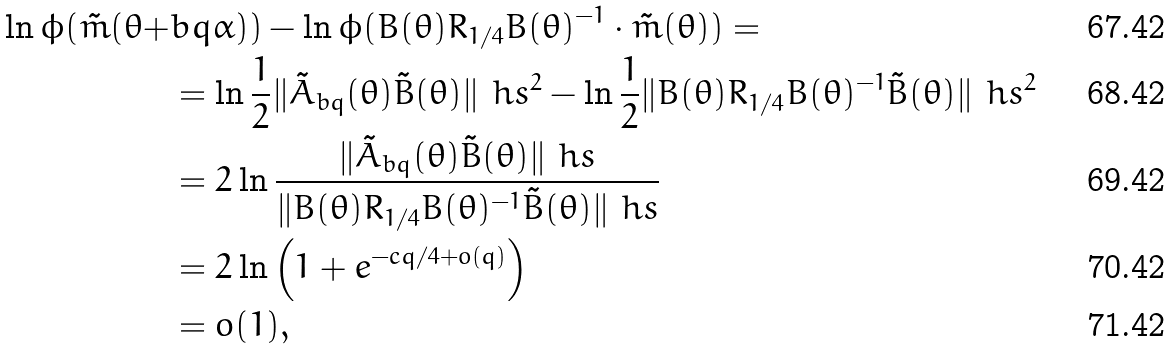Convert formula to latex. <formula><loc_0><loc_0><loc_500><loc_500>\ln \phi ( \tilde { m } ( \theta + & b q \alpha ) ) - \ln \phi ( B ( \theta ) R _ { 1 / 4 } B ( \theta ) ^ { - 1 } \cdot \tilde { m } ( \theta ) ) = \\ & = \ln \frac { 1 } { 2 } \| \tilde { A } _ { b q } ( \theta ) \tilde { B } ( \theta ) \| _ { \ } h s ^ { 2 } - \ln \frac { 1 } { 2 } \| B ( \theta ) R _ { 1 / 4 } B ( \theta ) ^ { - 1 } \tilde { B } ( \theta ) \| _ { \ } h s ^ { 2 } \\ & = 2 \ln \frac { \| \tilde { A } _ { b q } ( \theta ) \tilde { B } ( \theta ) \| _ { \ } h s } { \| B ( \theta ) R _ { 1 / 4 } B ( \theta ) ^ { - 1 } \tilde { B } ( \theta ) \| _ { \ } h s } \\ & = 2 \ln \left ( 1 + e ^ { - c q / 4 + o ( q ) } \right ) \\ & = o ( 1 ) ,</formula> 